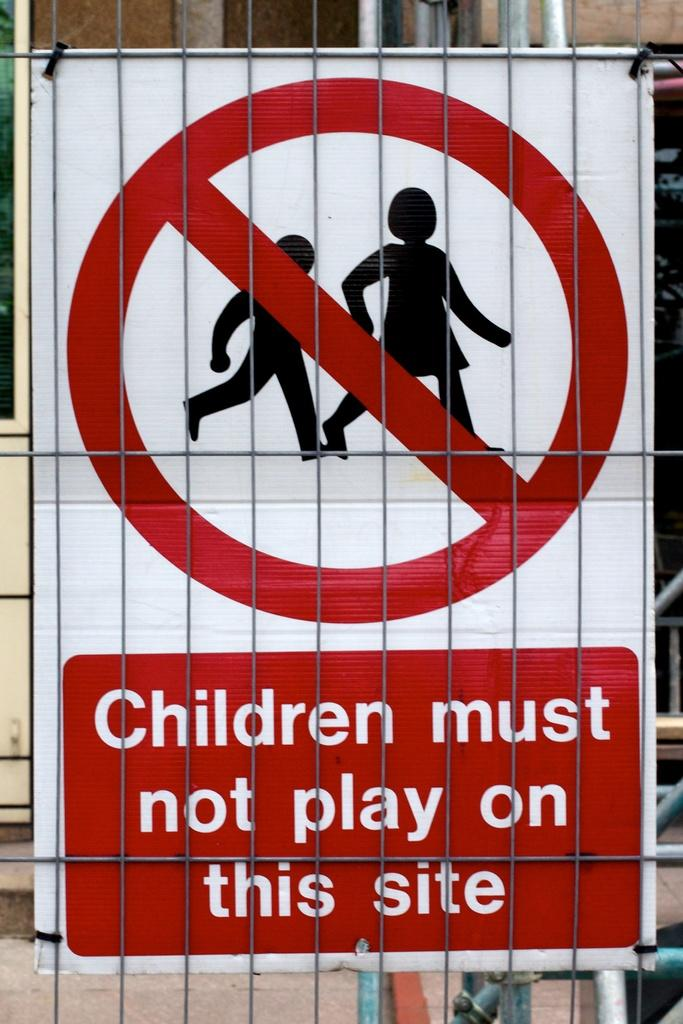<image>
Offer a succinct explanation of the picture presented. A signs states that, "Children must not play on this site." 